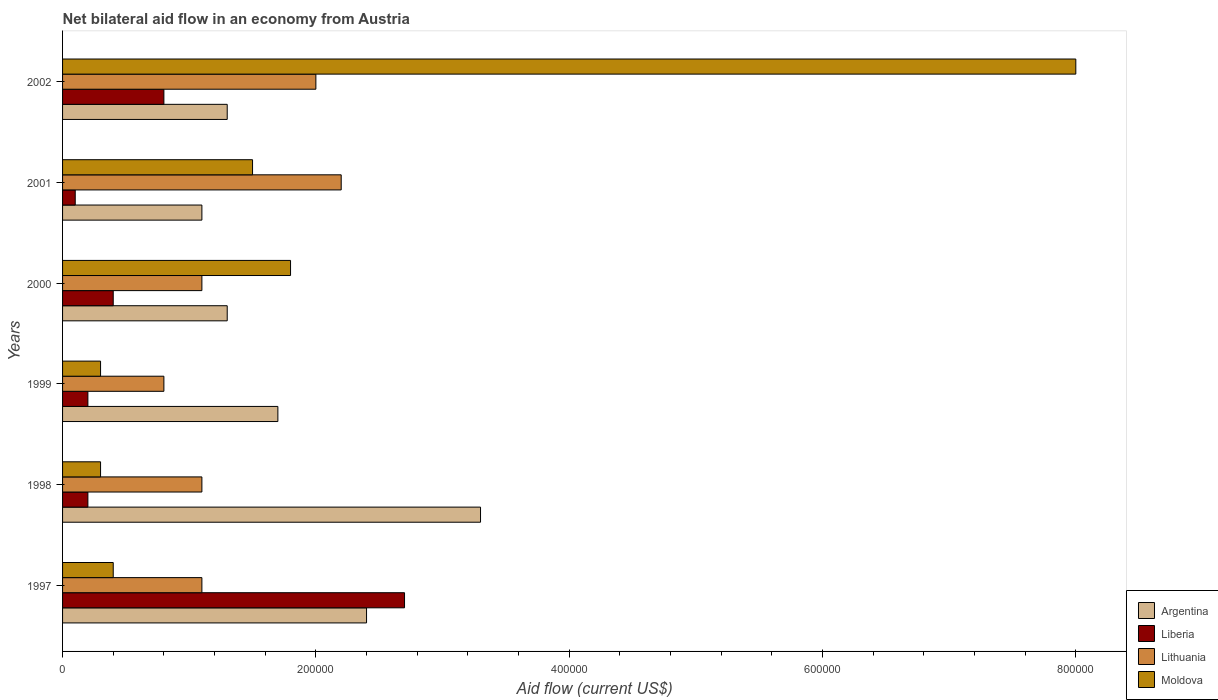How many groups of bars are there?
Your answer should be very brief. 6. Are the number of bars per tick equal to the number of legend labels?
Keep it short and to the point. Yes. Are the number of bars on each tick of the Y-axis equal?
Make the answer very short. Yes. How many bars are there on the 6th tick from the top?
Provide a short and direct response. 4. In which year was the net bilateral aid flow in Liberia maximum?
Your response must be concise. 1997. In which year was the net bilateral aid flow in Moldova minimum?
Provide a short and direct response. 1998. What is the total net bilateral aid flow in Liberia in the graph?
Make the answer very short. 4.40e+05. What is the difference between the net bilateral aid flow in Moldova in 1998 and the net bilateral aid flow in Liberia in 2001?
Ensure brevity in your answer.  2.00e+04. What is the average net bilateral aid flow in Argentina per year?
Provide a short and direct response. 1.85e+05. What is the ratio of the net bilateral aid flow in Moldova in 1997 to that in 1998?
Your response must be concise. 1.33. Is the net bilateral aid flow in Liberia in 2000 less than that in 2001?
Your answer should be compact. No. Is the difference between the net bilateral aid flow in Moldova in 1997 and 1998 greater than the difference between the net bilateral aid flow in Lithuania in 1997 and 1998?
Offer a terse response. Yes. In how many years, is the net bilateral aid flow in Liberia greater than the average net bilateral aid flow in Liberia taken over all years?
Ensure brevity in your answer.  2. What does the 4th bar from the top in 1999 represents?
Keep it short and to the point. Argentina. What does the 4th bar from the bottom in 2000 represents?
Your answer should be compact. Moldova. How many bars are there?
Provide a short and direct response. 24. Are all the bars in the graph horizontal?
Make the answer very short. Yes. What is the difference between two consecutive major ticks on the X-axis?
Offer a very short reply. 2.00e+05. Are the values on the major ticks of X-axis written in scientific E-notation?
Offer a terse response. No. How many legend labels are there?
Your answer should be compact. 4. What is the title of the graph?
Give a very brief answer. Net bilateral aid flow in an economy from Austria. Does "Afghanistan" appear as one of the legend labels in the graph?
Make the answer very short. No. What is the label or title of the Y-axis?
Offer a very short reply. Years. What is the Aid flow (current US$) in Lithuania in 1997?
Offer a terse response. 1.10e+05. What is the Aid flow (current US$) of Moldova in 1997?
Your answer should be compact. 4.00e+04. What is the Aid flow (current US$) of Moldova in 1998?
Your answer should be compact. 3.00e+04. What is the Aid flow (current US$) in Argentina in 1999?
Offer a terse response. 1.70e+05. What is the Aid flow (current US$) in Liberia in 1999?
Provide a short and direct response. 2.00e+04. What is the Aid flow (current US$) in Lithuania in 1999?
Keep it short and to the point. 8.00e+04. What is the Aid flow (current US$) in Moldova in 1999?
Give a very brief answer. 3.00e+04. What is the Aid flow (current US$) in Argentina in 2000?
Your answer should be compact. 1.30e+05. What is the Aid flow (current US$) of Liberia in 2000?
Provide a short and direct response. 4.00e+04. What is the Aid flow (current US$) of Moldova in 2000?
Give a very brief answer. 1.80e+05. What is the Aid flow (current US$) in Liberia in 2001?
Ensure brevity in your answer.  10000. What is the Aid flow (current US$) in Lithuania in 2001?
Keep it short and to the point. 2.20e+05. What is the Aid flow (current US$) in Moldova in 2001?
Ensure brevity in your answer.  1.50e+05. What is the Aid flow (current US$) in Liberia in 2002?
Make the answer very short. 8.00e+04. What is the Aid flow (current US$) of Lithuania in 2002?
Your answer should be very brief. 2.00e+05. What is the Aid flow (current US$) of Moldova in 2002?
Provide a short and direct response. 8.00e+05. Across all years, what is the maximum Aid flow (current US$) in Lithuania?
Make the answer very short. 2.20e+05. Across all years, what is the maximum Aid flow (current US$) of Moldova?
Provide a short and direct response. 8.00e+05. Across all years, what is the minimum Aid flow (current US$) in Argentina?
Your answer should be very brief. 1.10e+05. Across all years, what is the minimum Aid flow (current US$) of Lithuania?
Offer a terse response. 8.00e+04. Across all years, what is the minimum Aid flow (current US$) of Moldova?
Your answer should be compact. 3.00e+04. What is the total Aid flow (current US$) in Argentina in the graph?
Your answer should be very brief. 1.11e+06. What is the total Aid flow (current US$) of Lithuania in the graph?
Make the answer very short. 8.30e+05. What is the total Aid flow (current US$) of Moldova in the graph?
Provide a short and direct response. 1.23e+06. What is the difference between the Aid flow (current US$) of Lithuania in 1997 and that in 1998?
Provide a succinct answer. 0. What is the difference between the Aid flow (current US$) of Liberia in 1997 and that in 1999?
Offer a very short reply. 2.50e+05. What is the difference between the Aid flow (current US$) in Lithuania in 1997 and that in 1999?
Your answer should be compact. 3.00e+04. What is the difference between the Aid flow (current US$) in Moldova in 1997 and that in 1999?
Your answer should be compact. 10000. What is the difference between the Aid flow (current US$) of Lithuania in 1997 and that in 2000?
Give a very brief answer. 0. What is the difference between the Aid flow (current US$) in Liberia in 1997 and that in 2001?
Keep it short and to the point. 2.60e+05. What is the difference between the Aid flow (current US$) in Lithuania in 1997 and that in 2001?
Ensure brevity in your answer.  -1.10e+05. What is the difference between the Aid flow (current US$) of Argentina in 1997 and that in 2002?
Provide a short and direct response. 1.10e+05. What is the difference between the Aid flow (current US$) in Moldova in 1997 and that in 2002?
Provide a short and direct response. -7.60e+05. What is the difference between the Aid flow (current US$) in Argentina in 1998 and that in 1999?
Ensure brevity in your answer.  1.60e+05. What is the difference between the Aid flow (current US$) of Lithuania in 1998 and that in 2000?
Keep it short and to the point. 0. What is the difference between the Aid flow (current US$) of Moldova in 1998 and that in 2000?
Provide a short and direct response. -1.50e+05. What is the difference between the Aid flow (current US$) in Argentina in 1998 and that in 2001?
Ensure brevity in your answer.  2.20e+05. What is the difference between the Aid flow (current US$) in Lithuania in 1998 and that in 2001?
Offer a very short reply. -1.10e+05. What is the difference between the Aid flow (current US$) of Moldova in 1998 and that in 2001?
Offer a very short reply. -1.20e+05. What is the difference between the Aid flow (current US$) in Moldova in 1998 and that in 2002?
Give a very brief answer. -7.70e+05. What is the difference between the Aid flow (current US$) of Argentina in 1999 and that in 2000?
Offer a very short reply. 4.00e+04. What is the difference between the Aid flow (current US$) of Liberia in 1999 and that in 2000?
Provide a succinct answer. -2.00e+04. What is the difference between the Aid flow (current US$) of Lithuania in 1999 and that in 2000?
Offer a very short reply. -3.00e+04. What is the difference between the Aid flow (current US$) of Moldova in 1999 and that in 2000?
Give a very brief answer. -1.50e+05. What is the difference between the Aid flow (current US$) in Argentina in 1999 and that in 2001?
Make the answer very short. 6.00e+04. What is the difference between the Aid flow (current US$) of Moldova in 1999 and that in 2001?
Provide a succinct answer. -1.20e+05. What is the difference between the Aid flow (current US$) of Argentina in 1999 and that in 2002?
Your response must be concise. 4.00e+04. What is the difference between the Aid flow (current US$) in Liberia in 1999 and that in 2002?
Make the answer very short. -6.00e+04. What is the difference between the Aid flow (current US$) in Moldova in 1999 and that in 2002?
Ensure brevity in your answer.  -7.70e+05. What is the difference between the Aid flow (current US$) of Argentina in 2000 and that in 2001?
Your response must be concise. 2.00e+04. What is the difference between the Aid flow (current US$) of Liberia in 2000 and that in 2001?
Give a very brief answer. 3.00e+04. What is the difference between the Aid flow (current US$) of Liberia in 2000 and that in 2002?
Give a very brief answer. -4.00e+04. What is the difference between the Aid flow (current US$) in Lithuania in 2000 and that in 2002?
Your answer should be compact. -9.00e+04. What is the difference between the Aid flow (current US$) in Moldova in 2000 and that in 2002?
Keep it short and to the point. -6.20e+05. What is the difference between the Aid flow (current US$) of Moldova in 2001 and that in 2002?
Ensure brevity in your answer.  -6.50e+05. What is the difference between the Aid flow (current US$) of Argentina in 1997 and the Aid flow (current US$) of Lithuania in 1998?
Give a very brief answer. 1.30e+05. What is the difference between the Aid flow (current US$) in Argentina in 1997 and the Aid flow (current US$) in Moldova in 1998?
Ensure brevity in your answer.  2.10e+05. What is the difference between the Aid flow (current US$) of Liberia in 1997 and the Aid flow (current US$) of Moldova in 1998?
Ensure brevity in your answer.  2.40e+05. What is the difference between the Aid flow (current US$) of Argentina in 1997 and the Aid flow (current US$) of Liberia in 1999?
Provide a succinct answer. 2.20e+05. What is the difference between the Aid flow (current US$) of Argentina in 1997 and the Aid flow (current US$) of Lithuania in 1999?
Provide a short and direct response. 1.60e+05. What is the difference between the Aid flow (current US$) in Argentina in 1997 and the Aid flow (current US$) in Moldova in 1999?
Make the answer very short. 2.10e+05. What is the difference between the Aid flow (current US$) of Liberia in 1997 and the Aid flow (current US$) of Lithuania in 1999?
Your response must be concise. 1.90e+05. What is the difference between the Aid flow (current US$) in Liberia in 1997 and the Aid flow (current US$) in Moldova in 1999?
Your answer should be very brief. 2.40e+05. What is the difference between the Aid flow (current US$) in Argentina in 1997 and the Aid flow (current US$) in Liberia in 2000?
Provide a short and direct response. 2.00e+05. What is the difference between the Aid flow (current US$) in Argentina in 1997 and the Aid flow (current US$) in Lithuania in 2000?
Provide a short and direct response. 1.30e+05. What is the difference between the Aid flow (current US$) in Liberia in 1997 and the Aid flow (current US$) in Lithuania in 2000?
Make the answer very short. 1.60e+05. What is the difference between the Aid flow (current US$) in Lithuania in 1997 and the Aid flow (current US$) in Moldova in 2000?
Offer a terse response. -7.00e+04. What is the difference between the Aid flow (current US$) of Argentina in 1997 and the Aid flow (current US$) of Liberia in 2001?
Offer a very short reply. 2.30e+05. What is the difference between the Aid flow (current US$) in Argentina in 1997 and the Aid flow (current US$) in Lithuania in 2001?
Your answer should be very brief. 2.00e+04. What is the difference between the Aid flow (current US$) of Argentina in 1997 and the Aid flow (current US$) of Moldova in 2001?
Your answer should be very brief. 9.00e+04. What is the difference between the Aid flow (current US$) of Liberia in 1997 and the Aid flow (current US$) of Lithuania in 2001?
Give a very brief answer. 5.00e+04. What is the difference between the Aid flow (current US$) in Liberia in 1997 and the Aid flow (current US$) in Moldova in 2001?
Keep it short and to the point. 1.20e+05. What is the difference between the Aid flow (current US$) in Argentina in 1997 and the Aid flow (current US$) in Liberia in 2002?
Offer a terse response. 1.60e+05. What is the difference between the Aid flow (current US$) in Argentina in 1997 and the Aid flow (current US$) in Lithuania in 2002?
Your answer should be very brief. 4.00e+04. What is the difference between the Aid flow (current US$) in Argentina in 1997 and the Aid flow (current US$) in Moldova in 2002?
Give a very brief answer. -5.60e+05. What is the difference between the Aid flow (current US$) in Liberia in 1997 and the Aid flow (current US$) in Moldova in 2002?
Your response must be concise. -5.30e+05. What is the difference between the Aid flow (current US$) in Lithuania in 1997 and the Aid flow (current US$) in Moldova in 2002?
Provide a short and direct response. -6.90e+05. What is the difference between the Aid flow (current US$) of Argentina in 1998 and the Aid flow (current US$) of Liberia in 1999?
Keep it short and to the point. 3.10e+05. What is the difference between the Aid flow (current US$) in Argentina in 1998 and the Aid flow (current US$) in Lithuania in 1999?
Provide a short and direct response. 2.50e+05. What is the difference between the Aid flow (current US$) in Argentina in 1998 and the Aid flow (current US$) in Moldova in 1999?
Offer a terse response. 3.00e+05. What is the difference between the Aid flow (current US$) in Liberia in 1998 and the Aid flow (current US$) in Lithuania in 1999?
Your answer should be compact. -6.00e+04. What is the difference between the Aid flow (current US$) of Liberia in 1998 and the Aid flow (current US$) of Moldova in 1999?
Offer a very short reply. -10000. What is the difference between the Aid flow (current US$) of Lithuania in 1998 and the Aid flow (current US$) of Moldova in 1999?
Provide a succinct answer. 8.00e+04. What is the difference between the Aid flow (current US$) of Argentina in 1998 and the Aid flow (current US$) of Lithuania in 2000?
Give a very brief answer. 2.20e+05. What is the difference between the Aid flow (current US$) of Liberia in 1998 and the Aid flow (current US$) of Lithuania in 2000?
Provide a succinct answer. -9.00e+04. What is the difference between the Aid flow (current US$) of Argentina in 1998 and the Aid flow (current US$) of Liberia in 2001?
Offer a terse response. 3.20e+05. What is the difference between the Aid flow (current US$) in Argentina in 1998 and the Aid flow (current US$) in Moldova in 2001?
Offer a very short reply. 1.80e+05. What is the difference between the Aid flow (current US$) of Lithuania in 1998 and the Aid flow (current US$) of Moldova in 2001?
Make the answer very short. -4.00e+04. What is the difference between the Aid flow (current US$) in Argentina in 1998 and the Aid flow (current US$) in Liberia in 2002?
Provide a succinct answer. 2.50e+05. What is the difference between the Aid flow (current US$) in Argentina in 1998 and the Aid flow (current US$) in Lithuania in 2002?
Your response must be concise. 1.30e+05. What is the difference between the Aid flow (current US$) in Argentina in 1998 and the Aid flow (current US$) in Moldova in 2002?
Make the answer very short. -4.70e+05. What is the difference between the Aid flow (current US$) of Liberia in 1998 and the Aid flow (current US$) of Moldova in 2002?
Make the answer very short. -7.80e+05. What is the difference between the Aid flow (current US$) in Lithuania in 1998 and the Aid flow (current US$) in Moldova in 2002?
Your answer should be compact. -6.90e+05. What is the difference between the Aid flow (current US$) in Argentina in 1999 and the Aid flow (current US$) in Liberia in 2000?
Your response must be concise. 1.30e+05. What is the difference between the Aid flow (current US$) in Argentina in 1999 and the Aid flow (current US$) in Lithuania in 2000?
Give a very brief answer. 6.00e+04. What is the difference between the Aid flow (current US$) in Liberia in 1999 and the Aid flow (current US$) in Lithuania in 2000?
Provide a short and direct response. -9.00e+04. What is the difference between the Aid flow (current US$) in Lithuania in 1999 and the Aid flow (current US$) in Moldova in 2000?
Provide a succinct answer. -1.00e+05. What is the difference between the Aid flow (current US$) of Argentina in 1999 and the Aid flow (current US$) of Liberia in 2001?
Offer a very short reply. 1.60e+05. What is the difference between the Aid flow (current US$) of Argentina in 1999 and the Aid flow (current US$) of Lithuania in 2001?
Your response must be concise. -5.00e+04. What is the difference between the Aid flow (current US$) in Argentina in 1999 and the Aid flow (current US$) in Moldova in 2001?
Make the answer very short. 2.00e+04. What is the difference between the Aid flow (current US$) of Liberia in 1999 and the Aid flow (current US$) of Lithuania in 2001?
Your response must be concise. -2.00e+05. What is the difference between the Aid flow (current US$) of Argentina in 1999 and the Aid flow (current US$) of Liberia in 2002?
Offer a terse response. 9.00e+04. What is the difference between the Aid flow (current US$) of Argentina in 1999 and the Aid flow (current US$) of Moldova in 2002?
Your answer should be very brief. -6.30e+05. What is the difference between the Aid flow (current US$) of Liberia in 1999 and the Aid flow (current US$) of Moldova in 2002?
Your answer should be very brief. -7.80e+05. What is the difference between the Aid flow (current US$) of Lithuania in 1999 and the Aid flow (current US$) of Moldova in 2002?
Provide a succinct answer. -7.20e+05. What is the difference between the Aid flow (current US$) of Argentina in 2000 and the Aid flow (current US$) of Lithuania in 2001?
Provide a short and direct response. -9.00e+04. What is the difference between the Aid flow (current US$) of Argentina in 2000 and the Aid flow (current US$) of Liberia in 2002?
Your answer should be very brief. 5.00e+04. What is the difference between the Aid flow (current US$) in Argentina in 2000 and the Aid flow (current US$) in Moldova in 2002?
Your response must be concise. -6.70e+05. What is the difference between the Aid flow (current US$) of Liberia in 2000 and the Aid flow (current US$) of Moldova in 2002?
Make the answer very short. -7.60e+05. What is the difference between the Aid flow (current US$) of Lithuania in 2000 and the Aid flow (current US$) of Moldova in 2002?
Your response must be concise. -6.90e+05. What is the difference between the Aid flow (current US$) of Argentina in 2001 and the Aid flow (current US$) of Liberia in 2002?
Ensure brevity in your answer.  3.00e+04. What is the difference between the Aid flow (current US$) in Argentina in 2001 and the Aid flow (current US$) in Moldova in 2002?
Your answer should be compact. -6.90e+05. What is the difference between the Aid flow (current US$) of Liberia in 2001 and the Aid flow (current US$) of Moldova in 2002?
Provide a short and direct response. -7.90e+05. What is the difference between the Aid flow (current US$) in Lithuania in 2001 and the Aid flow (current US$) in Moldova in 2002?
Give a very brief answer. -5.80e+05. What is the average Aid flow (current US$) of Argentina per year?
Your response must be concise. 1.85e+05. What is the average Aid flow (current US$) of Liberia per year?
Make the answer very short. 7.33e+04. What is the average Aid flow (current US$) of Lithuania per year?
Offer a terse response. 1.38e+05. What is the average Aid flow (current US$) in Moldova per year?
Provide a short and direct response. 2.05e+05. In the year 1997, what is the difference between the Aid flow (current US$) in Argentina and Aid flow (current US$) in Moldova?
Provide a succinct answer. 2.00e+05. In the year 1997, what is the difference between the Aid flow (current US$) of Liberia and Aid flow (current US$) of Lithuania?
Your answer should be very brief. 1.60e+05. In the year 1998, what is the difference between the Aid flow (current US$) in Argentina and Aid flow (current US$) in Liberia?
Offer a terse response. 3.10e+05. In the year 1998, what is the difference between the Aid flow (current US$) of Argentina and Aid flow (current US$) of Moldova?
Give a very brief answer. 3.00e+05. In the year 1998, what is the difference between the Aid flow (current US$) of Liberia and Aid flow (current US$) of Lithuania?
Ensure brevity in your answer.  -9.00e+04. In the year 1999, what is the difference between the Aid flow (current US$) in Argentina and Aid flow (current US$) in Lithuania?
Provide a succinct answer. 9.00e+04. In the year 1999, what is the difference between the Aid flow (current US$) of Liberia and Aid flow (current US$) of Moldova?
Your response must be concise. -10000. In the year 1999, what is the difference between the Aid flow (current US$) in Lithuania and Aid flow (current US$) in Moldova?
Give a very brief answer. 5.00e+04. In the year 2000, what is the difference between the Aid flow (current US$) in Argentina and Aid flow (current US$) in Lithuania?
Your answer should be compact. 2.00e+04. In the year 2000, what is the difference between the Aid flow (current US$) in Liberia and Aid flow (current US$) in Moldova?
Offer a terse response. -1.40e+05. In the year 2001, what is the difference between the Aid flow (current US$) of Argentina and Aid flow (current US$) of Lithuania?
Keep it short and to the point. -1.10e+05. In the year 2001, what is the difference between the Aid flow (current US$) of Liberia and Aid flow (current US$) of Moldova?
Keep it short and to the point. -1.40e+05. In the year 2002, what is the difference between the Aid flow (current US$) in Argentina and Aid flow (current US$) in Liberia?
Ensure brevity in your answer.  5.00e+04. In the year 2002, what is the difference between the Aid flow (current US$) in Argentina and Aid flow (current US$) in Lithuania?
Your answer should be very brief. -7.00e+04. In the year 2002, what is the difference between the Aid flow (current US$) in Argentina and Aid flow (current US$) in Moldova?
Keep it short and to the point. -6.70e+05. In the year 2002, what is the difference between the Aid flow (current US$) in Liberia and Aid flow (current US$) in Moldova?
Ensure brevity in your answer.  -7.20e+05. In the year 2002, what is the difference between the Aid flow (current US$) in Lithuania and Aid flow (current US$) in Moldova?
Give a very brief answer. -6.00e+05. What is the ratio of the Aid flow (current US$) in Argentina in 1997 to that in 1998?
Make the answer very short. 0.73. What is the ratio of the Aid flow (current US$) of Lithuania in 1997 to that in 1998?
Your answer should be very brief. 1. What is the ratio of the Aid flow (current US$) in Moldova in 1997 to that in 1998?
Give a very brief answer. 1.33. What is the ratio of the Aid flow (current US$) in Argentina in 1997 to that in 1999?
Provide a succinct answer. 1.41. What is the ratio of the Aid flow (current US$) of Lithuania in 1997 to that in 1999?
Provide a succinct answer. 1.38. What is the ratio of the Aid flow (current US$) in Moldova in 1997 to that in 1999?
Your answer should be very brief. 1.33. What is the ratio of the Aid flow (current US$) in Argentina in 1997 to that in 2000?
Your response must be concise. 1.85. What is the ratio of the Aid flow (current US$) in Liberia in 1997 to that in 2000?
Provide a short and direct response. 6.75. What is the ratio of the Aid flow (current US$) in Lithuania in 1997 to that in 2000?
Your answer should be very brief. 1. What is the ratio of the Aid flow (current US$) of Moldova in 1997 to that in 2000?
Your answer should be very brief. 0.22. What is the ratio of the Aid flow (current US$) in Argentina in 1997 to that in 2001?
Your response must be concise. 2.18. What is the ratio of the Aid flow (current US$) of Lithuania in 1997 to that in 2001?
Your response must be concise. 0.5. What is the ratio of the Aid flow (current US$) in Moldova in 1997 to that in 2001?
Offer a very short reply. 0.27. What is the ratio of the Aid flow (current US$) in Argentina in 1997 to that in 2002?
Ensure brevity in your answer.  1.85. What is the ratio of the Aid flow (current US$) in Liberia in 1997 to that in 2002?
Keep it short and to the point. 3.38. What is the ratio of the Aid flow (current US$) of Lithuania in 1997 to that in 2002?
Ensure brevity in your answer.  0.55. What is the ratio of the Aid flow (current US$) in Moldova in 1997 to that in 2002?
Keep it short and to the point. 0.05. What is the ratio of the Aid flow (current US$) in Argentina in 1998 to that in 1999?
Ensure brevity in your answer.  1.94. What is the ratio of the Aid flow (current US$) in Lithuania in 1998 to that in 1999?
Give a very brief answer. 1.38. What is the ratio of the Aid flow (current US$) in Moldova in 1998 to that in 1999?
Provide a short and direct response. 1. What is the ratio of the Aid flow (current US$) in Argentina in 1998 to that in 2000?
Give a very brief answer. 2.54. What is the ratio of the Aid flow (current US$) of Lithuania in 1998 to that in 2000?
Offer a terse response. 1. What is the ratio of the Aid flow (current US$) of Moldova in 1998 to that in 2000?
Your response must be concise. 0.17. What is the ratio of the Aid flow (current US$) of Argentina in 1998 to that in 2001?
Offer a terse response. 3. What is the ratio of the Aid flow (current US$) in Liberia in 1998 to that in 2001?
Your response must be concise. 2. What is the ratio of the Aid flow (current US$) in Lithuania in 1998 to that in 2001?
Your answer should be very brief. 0.5. What is the ratio of the Aid flow (current US$) of Argentina in 1998 to that in 2002?
Keep it short and to the point. 2.54. What is the ratio of the Aid flow (current US$) in Liberia in 1998 to that in 2002?
Your answer should be compact. 0.25. What is the ratio of the Aid flow (current US$) in Lithuania in 1998 to that in 2002?
Give a very brief answer. 0.55. What is the ratio of the Aid flow (current US$) of Moldova in 1998 to that in 2002?
Ensure brevity in your answer.  0.04. What is the ratio of the Aid flow (current US$) in Argentina in 1999 to that in 2000?
Offer a very short reply. 1.31. What is the ratio of the Aid flow (current US$) of Liberia in 1999 to that in 2000?
Offer a terse response. 0.5. What is the ratio of the Aid flow (current US$) of Lithuania in 1999 to that in 2000?
Your answer should be compact. 0.73. What is the ratio of the Aid flow (current US$) of Moldova in 1999 to that in 2000?
Offer a very short reply. 0.17. What is the ratio of the Aid flow (current US$) of Argentina in 1999 to that in 2001?
Your answer should be compact. 1.55. What is the ratio of the Aid flow (current US$) in Lithuania in 1999 to that in 2001?
Offer a terse response. 0.36. What is the ratio of the Aid flow (current US$) of Argentina in 1999 to that in 2002?
Keep it short and to the point. 1.31. What is the ratio of the Aid flow (current US$) of Moldova in 1999 to that in 2002?
Your answer should be very brief. 0.04. What is the ratio of the Aid flow (current US$) in Argentina in 2000 to that in 2001?
Your answer should be compact. 1.18. What is the ratio of the Aid flow (current US$) in Lithuania in 2000 to that in 2002?
Give a very brief answer. 0.55. What is the ratio of the Aid flow (current US$) of Moldova in 2000 to that in 2002?
Your answer should be very brief. 0.23. What is the ratio of the Aid flow (current US$) in Argentina in 2001 to that in 2002?
Keep it short and to the point. 0.85. What is the ratio of the Aid flow (current US$) of Moldova in 2001 to that in 2002?
Make the answer very short. 0.19. What is the difference between the highest and the second highest Aid flow (current US$) in Argentina?
Provide a short and direct response. 9.00e+04. What is the difference between the highest and the second highest Aid flow (current US$) in Liberia?
Your answer should be very brief. 1.90e+05. What is the difference between the highest and the second highest Aid flow (current US$) in Moldova?
Your answer should be very brief. 6.20e+05. What is the difference between the highest and the lowest Aid flow (current US$) of Moldova?
Keep it short and to the point. 7.70e+05. 